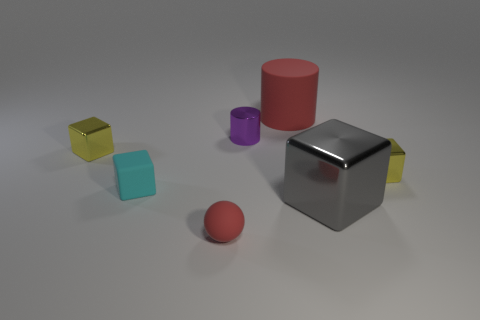Subtract all tiny blocks. How many blocks are left? 1 Subtract all purple cylinders. How many cylinders are left? 1 Subtract all blocks. How many objects are left? 3 Subtract all cyan cylinders. Subtract all red blocks. How many cylinders are left? 2 Add 1 tiny purple metal cubes. How many objects exist? 8 Subtract 0 blue spheres. How many objects are left? 7 Subtract 1 spheres. How many spheres are left? 0 Subtract all gray cubes. How many blue cylinders are left? 0 Subtract all large brown matte objects. Subtract all gray shiny objects. How many objects are left? 6 Add 5 tiny cubes. How many tiny cubes are left? 8 